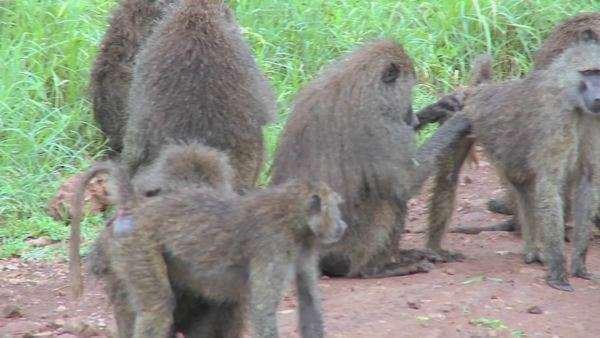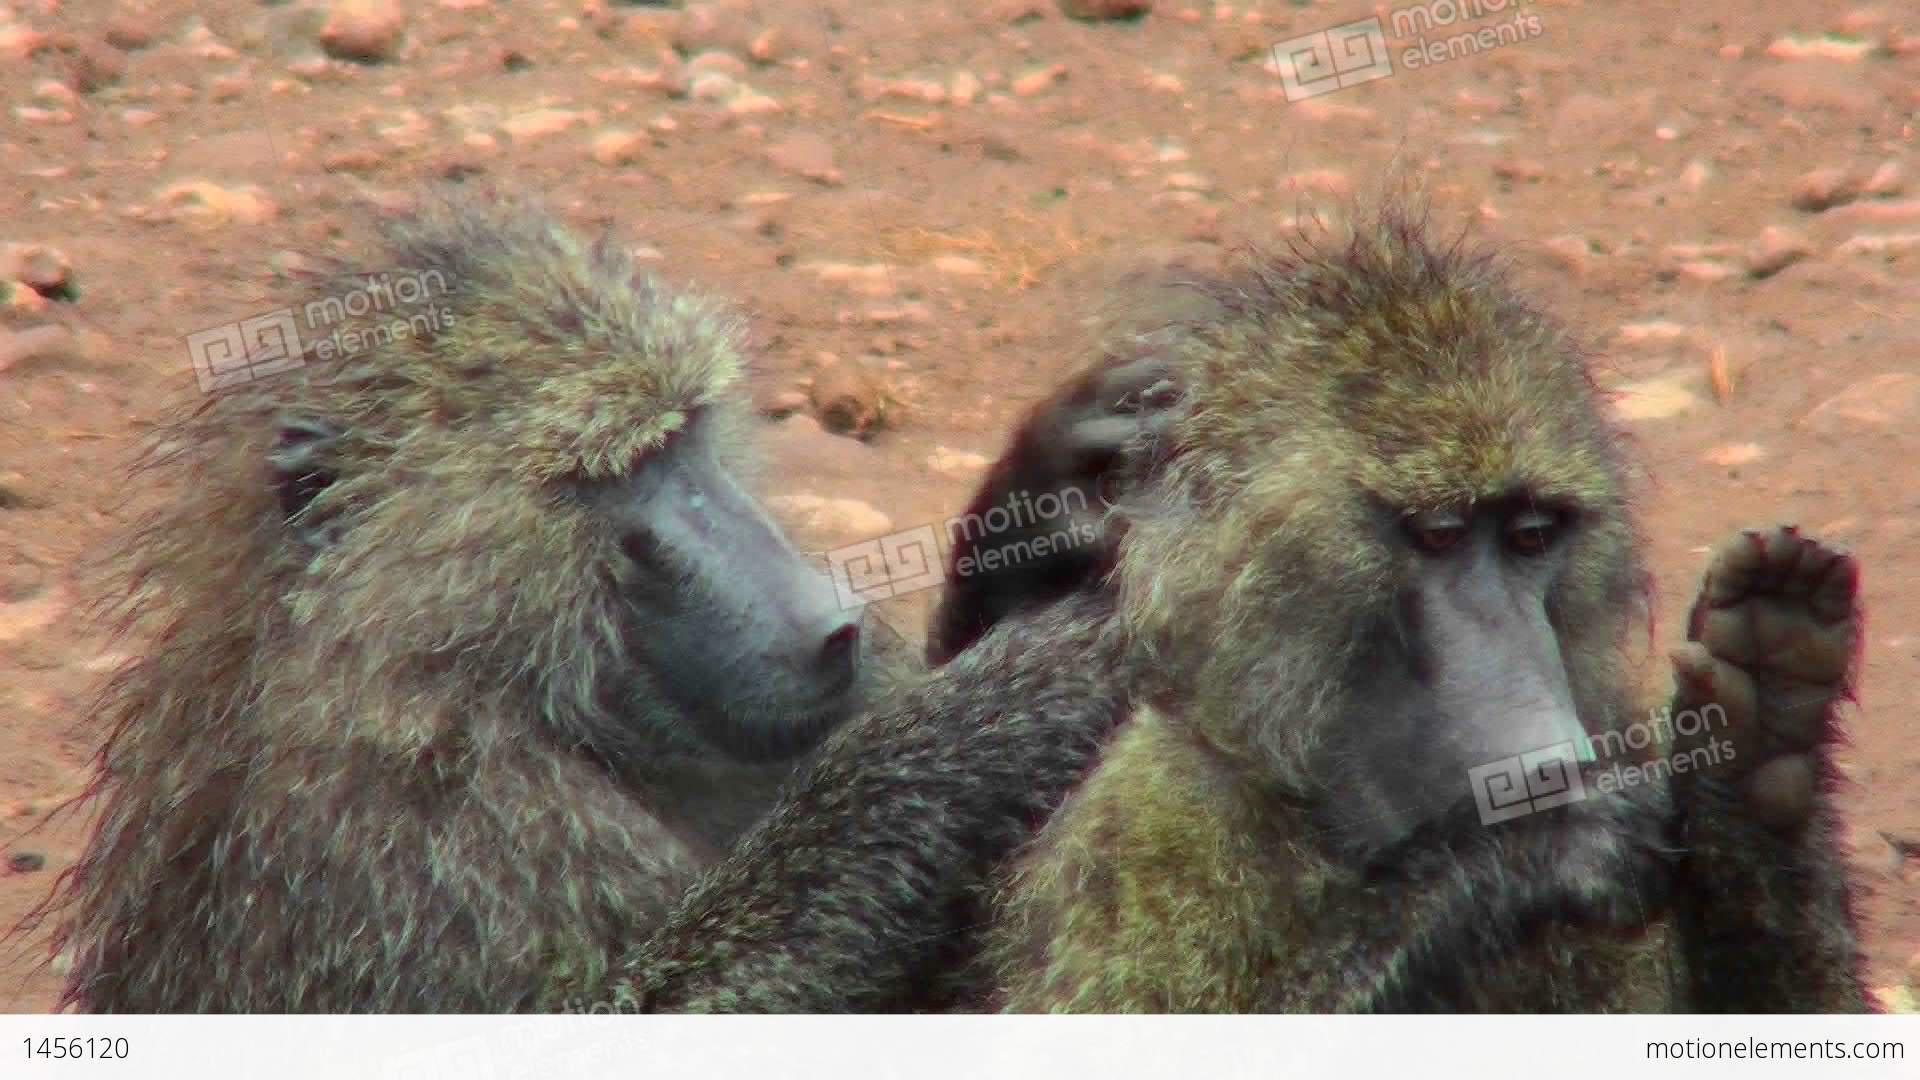The first image is the image on the left, the second image is the image on the right. Considering the images on both sides, is "a baboon is grooming another baboon's leg while it lays down" valid? Answer yes or no. No. The first image is the image on the left, the second image is the image on the right. For the images displayed, is the sentence "There are exactly four apes." factually correct? Answer yes or no. No. 